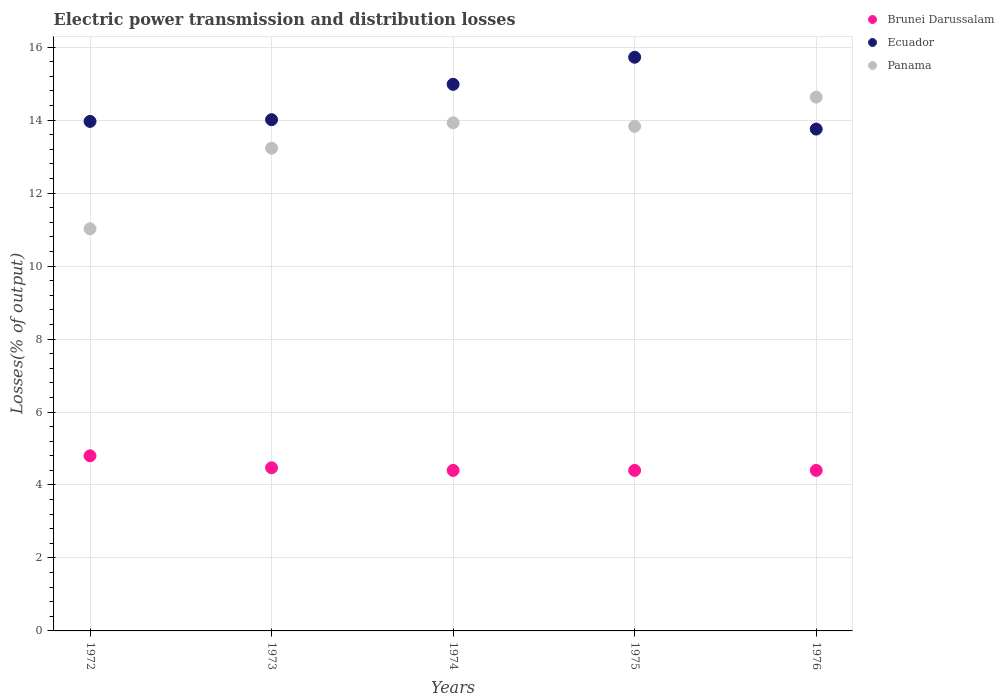How many different coloured dotlines are there?
Offer a very short reply. 3. Across all years, what is the maximum electric power transmission and distribution losses in Brunei Darussalam?
Ensure brevity in your answer.  4.8. Across all years, what is the minimum electric power transmission and distribution losses in Ecuador?
Provide a succinct answer. 13.76. In which year was the electric power transmission and distribution losses in Brunei Darussalam maximum?
Your answer should be very brief. 1972. In which year was the electric power transmission and distribution losses in Brunei Darussalam minimum?
Your response must be concise. 1974. What is the total electric power transmission and distribution losses in Ecuador in the graph?
Keep it short and to the point. 72.44. What is the difference between the electric power transmission and distribution losses in Ecuador in 1973 and that in 1976?
Your answer should be compact. 0.26. What is the difference between the electric power transmission and distribution losses in Brunei Darussalam in 1972 and the electric power transmission and distribution losses in Panama in 1976?
Offer a very short reply. -9.83. What is the average electric power transmission and distribution losses in Ecuador per year?
Your answer should be very brief. 14.49. In the year 1973, what is the difference between the electric power transmission and distribution losses in Panama and electric power transmission and distribution losses in Ecuador?
Ensure brevity in your answer.  -0.78. In how many years, is the electric power transmission and distribution losses in Brunei Darussalam greater than 6.8 %?
Your answer should be compact. 0. What is the ratio of the electric power transmission and distribution losses in Brunei Darussalam in 1972 to that in 1976?
Give a very brief answer. 1.09. Is the difference between the electric power transmission and distribution losses in Panama in 1973 and 1974 greater than the difference between the electric power transmission and distribution losses in Ecuador in 1973 and 1974?
Offer a terse response. Yes. What is the difference between the highest and the second highest electric power transmission and distribution losses in Ecuador?
Offer a very short reply. 0.74. What is the difference between the highest and the lowest electric power transmission and distribution losses in Ecuador?
Provide a succinct answer. 1.97. Is the sum of the electric power transmission and distribution losses in Ecuador in 1972 and 1973 greater than the maximum electric power transmission and distribution losses in Brunei Darussalam across all years?
Keep it short and to the point. Yes. Is it the case that in every year, the sum of the electric power transmission and distribution losses in Ecuador and electric power transmission and distribution losses in Brunei Darussalam  is greater than the electric power transmission and distribution losses in Panama?
Your answer should be compact. Yes. Does the electric power transmission and distribution losses in Brunei Darussalam monotonically increase over the years?
Provide a succinct answer. No. How many dotlines are there?
Ensure brevity in your answer.  3. How many years are there in the graph?
Make the answer very short. 5. What is the difference between two consecutive major ticks on the Y-axis?
Ensure brevity in your answer.  2. Does the graph contain grids?
Offer a terse response. Yes. What is the title of the graph?
Your answer should be very brief. Electric power transmission and distribution losses. Does "Gabon" appear as one of the legend labels in the graph?
Keep it short and to the point. No. What is the label or title of the X-axis?
Your answer should be very brief. Years. What is the label or title of the Y-axis?
Provide a short and direct response. Losses(% of output). What is the Losses(% of output) in Ecuador in 1972?
Provide a succinct answer. 13.97. What is the Losses(% of output) of Panama in 1972?
Give a very brief answer. 11.02. What is the Losses(% of output) in Brunei Darussalam in 1973?
Ensure brevity in your answer.  4.47. What is the Losses(% of output) in Ecuador in 1973?
Your response must be concise. 14.01. What is the Losses(% of output) of Panama in 1973?
Your response must be concise. 13.23. What is the Losses(% of output) in Ecuador in 1974?
Offer a very short reply. 14.98. What is the Losses(% of output) of Panama in 1974?
Your answer should be very brief. 13.93. What is the Losses(% of output) in Brunei Darussalam in 1975?
Provide a succinct answer. 4.4. What is the Losses(% of output) of Ecuador in 1975?
Provide a succinct answer. 15.72. What is the Losses(% of output) in Panama in 1975?
Provide a short and direct response. 13.83. What is the Losses(% of output) in Ecuador in 1976?
Your response must be concise. 13.76. What is the Losses(% of output) of Panama in 1976?
Your answer should be compact. 14.63. Across all years, what is the maximum Losses(% of output) in Brunei Darussalam?
Provide a succinct answer. 4.8. Across all years, what is the maximum Losses(% of output) in Ecuador?
Keep it short and to the point. 15.72. Across all years, what is the maximum Losses(% of output) in Panama?
Ensure brevity in your answer.  14.63. Across all years, what is the minimum Losses(% of output) in Ecuador?
Ensure brevity in your answer.  13.76. Across all years, what is the minimum Losses(% of output) in Panama?
Ensure brevity in your answer.  11.02. What is the total Losses(% of output) of Brunei Darussalam in the graph?
Offer a terse response. 22.47. What is the total Losses(% of output) in Ecuador in the graph?
Your answer should be very brief. 72.44. What is the total Losses(% of output) in Panama in the graph?
Offer a terse response. 66.64. What is the difference between the Losses(% of output) of Brunei Darussalam in 1972 and that in 1973?
Make the answer very short. 0.33. What is the difference between the Losses(% of output) of Ecuador in 1972 and that in 1973?
Provide a succinct answer. -0.05. What is the difference between the Losses(% of output) in Panama in 1972 and that in 1973?
Ensure brevity in your answer.  -2.21. What is the difference between the Losses(% of output) of Ecuador in 1972 and that in 1974?
Provide a short and direct response. -1.02. What is the difference between the Losses(% of output) in Panama in 1972 and that in 1974?
Your answer should be very brief. -2.91. What is the difference between the Losses(% of output) in Ecuador in 1972 and that in 1975?
Your answer should be very brief. -1.76. What is the difference between the Losses(% of output) in Panama in 1972 and that in 1975?
Give a very brief answer. -2.81. What is the difference between the Losses(% of output) of Ecuador in 1972 and that in 1976?
Offer a very short reply. 0.21. What is the difference between the Losses(% of output) of Panama in 1972 and that in 1976?
Offer a terse response. -3.61. What is the difference between the Losses(% of output) of Brunei Darussalam in 1973 and that in 1974?
Offer a very short reply. 0.07. What is the difference between the Losses(% of output) of Ecuador in 1973 and that in 1974?
Give a very brief answer. -0.97. What is the difference between the Losses(% of output) of Panama in 1973 and that in 1974?
Offer a very short reply. -0.7. What is the difference between the Losses(% of output) of Brunei Darussalam in 1973 and that in 1975?
Your response must be concise. 0.07. What is the difference between the Losses(% of output) in Ecuador in 1973 and that in 1975?
Offer a very short reply. -1.71. What is the difference between the Losses(% of output) in Panama in 1973 and that in 1975?
Make the answer very short. -0.6. What is the difference between the Losses(% of output) in Brunei Darussalam in 1973 and that in 1976?
Your response must be concise. 0.07. What is the difference between the Losses(% of output) in Ecuador in 1973 and that in 1976?
Give a very brief answer. 0.26. What is the difference between the Losses(% of output) of Panama in 1973 and that in 1976?
Make the answer very short. -1.4. What is the difference between the Losses(% of output) of Brunei Darussalam in 1974 and that in 1975?
Offer a very short reply. 0. What is the difference between the Losses(% of output) in Ecuador in 1974 and that in 1975?
Keep it short and to the point. -0.74. What is the difference between the Losses(% of output) in Panama in 1974 and that in 1975?
Ensure brevity in your answer.  0.1. What is the difference between the Losses(% of output) of Ecuador in 1974 and that in 1976?
Make the answer very short. 1.23. What is the difference between the Losses(% of output) in Panama in 1974 and that in 1976?
Offer a terse response. -0.7. What is the difference between the Losses(% of output) in Ecuador in 1975 and that in 1976?
Offer a terse response. 1.97. What is the difference between the Losses(% of output) of Panama in 1975 and that in 1976?
Give a very brief answer. -0.8. What is the difference between the Losses(% of output) in Brunei Darussalam in 1972 and the Losses(% of output) in Ecuador in 1973?
Your response must be concise. -9.21. What is the difference between the Losses(% of output) of Brunei Darussalam in 1972 and the Losses(% of output) of Panama in 1973?
Keep it short and to the point. -8.43. What is the difference between the Losses(% of output) of Ecuador in 1972 and the Losses(% of output) of Panama in 1973?
Your answer should be compact. 0.73. What is the difference between the Losses(% of output) in Brunei Darussalam in 1972 and the Losses(% of output) in Ecuador in 1974?
Provide a succinct answer. -10.18. What is the difference between the Losses(% of output) of Brunei Darussalam in 1972 and the Losses(% of output) of Panama in 1974?
Provide a succinct answer. -9.13. What is the difference between the Losses(% of output) in Ecuador in 1972 and the Losses(% of output) in Panama in 1974?
Provide a succinct answer. 0.04. What is the difference between the Losses(% of output) in Brunei Darussalam in 1972 and the Losses(% of output) in Ecuador in 1975?
Keep it short and to the point. -10.92. What is the difference between the Losses(% of output) of Brunei Darussalam in 1972 and the Losses(% of output) of Panama in 1975?
Keep it short and to the point. -9.03. What is the difference between the Losses(% of output) of Ecuador in 1972 and the Losses(% of output) of Panama in 1975?
Provide a succinct answer. 0.14. What is the difference between the Losses(% of output) of Brunei Darussalam in 1972 and the Losses(% of output) of Ecuador in 1976?
Your answer should be very brief. -8.96. What is the difference between the Losses(% of output) in Brunei Darussalam in 1972 and the Losses(% of output) in Panama in 1976?
Your answer should be very brief. -9.83. What is the difference between the Losses(% of output) of Ecuador in 1972 and the Losses(% of output) of Panama in 1976?
Your answer should be compact. -0.66. What is the difference between the Losses(% of output) of Brunei Darussalam in 1973 and the Losses(% of output) of Ecuador in 1974?
Offer a very short reply. -10.51. What is the difference between the Losses(% of output) in Brunei Darussalam in 1973 and the Losses(% of output) in Panama in 1974?
Ensure brevity in your answer.  -9.46. What is the difference between the Losses(% of output) in Ecuador in 1973 and the Losses(% of output) in Panama in 1974?
Offer a terse response. 0.08. What is the difference between the Losses(% of output) of Brunei Darussalam in 1973 and the Losses(% of output) of Ecuador in 1975?
Ensure brevity in your answer.  -11.25. What is the difference between the Losses(% of output) of Brunei Darussalam in 1973 and the Losses(% of output) of Panama in 1975?
Provide a short and direct response. -9.36. What is the difference between the Losses(% of output) of Ecuador in 1973 and the Losses(% of output) of Panama in 1975?
Ensure brevity in your answer.  0.18. What is the difference between the Losses(% of output) of Brunei Darussalam in 1973 and the Losses(% of output) of Ecuador in 1976?
Your answer should be very brief. -9.28. What is the difference between the Losses(% of output) in Brunei Darussalam in 1973 and the Losses(% of output) in Panama in 1976?
Keep it short and to the point. -10.16. What is the difference between the Losses(% of output) of Ecuador in 1973 and the Losses(% of output) of Panama in 1976?
Provide a short and direct response. -0.62. What is the difference between the Losses(% of output) in Brunei Darussalam in 1974 and the Losses(% of output) in Ecuador in 1975?
Your response must be concise. -11.32. What is the difference between the Losses(% of output) in Brunei Darussalam in 1974 and the Losses(% of output) in Panama in 1975?
Give a very brief answer. -9.43. What is the difference between the Losses(% of output) of Ecuador in 1974 and the Losses(% of output) of Panama in 1975?
Give a very brief answer. 1.15. What is the difference between the Losses(% of output) in Brunei Darussalam in 1974 and the Losses(% of output) in Ecuador in 1976?
Ensure brevity in your answer.  -9.36. What is the difference between the Losses(% of output) in Brunei Darussalam in 1974 and the Losses(% of output) in Panama in 1976?
Ensure brevity in your answer.  -10.23. What is the difference between the Losses(% of output) in Ecuador in 1974 and the Losses(% of output) in Panama in 1976?
Make the answer very short. 0.35. What is the difference between the Losses(% of output) of Brunei Darussalam in 1975 and the Losses(% of output) of Ecuador in 1976?
Your response must be concise. -9.36. What is the difference between the Losses(% of output) of Brunei Darussalam in 1975 and the Losses(% of output) of Panama in 1976?
Ensure brevity in your answer.  -10.23. What is the difference between the Losses(% of output) of Ecuador in 1975 and the Losses(% of output) of Panama in 1976?
Your answer should be compact. 1.09. What is the average Losses(% of output) of Brunei Darussalam per year?
Keep it short and to the point. 4.49. What is the average Losses(% of output) of Ecuador per year?
Offer a very short reply. 14.49. What is the average Losses(% of output) in Panama per year?
Ensure brevity in your answer.  13.33. In the year 1972, what is the difference between the Losses(% of output) of Brunei Darussalam and Losses(% of output) of Ecuador?
Offer a terse response. -9.17. In the year 1972, what is the difference between the Losses(% of output) in Brunei Darussalam and Losses(% of output) in Panama?
Give a very brief answer. -6.22. In the year 1972, what is the difference between the Losses(% of output) of Ecuador and Losses(% of output) of Panama?
Your answer should be very brief. 2.94. In the year 1973, what is the difference between the Losses(% of output) in Brunei Darussalam and Losses(% of output) in Ecuador?
Offer a very short reply. -9.54. In the year 1973, what is the difference between the Losses(% of output) of Brunei Darussalam and Losses(% of output) of Panama?
Offer a very short reply. -8.76. In the year 1973, what is the difference between the Losses(% of output) in Ecuador and Losses(% of output) in Panama?
Your response must be concise. 0.78. In the year 1974, what is the difference between the Losses(% of output) of Brunei Darussalam and Losses(% of output) of Ecuador?
Give a very brief answer. -10.58. In the year 1974, what is the difference between the Losses(% of output) of Brunei Darussalam and Losses(% of output) of Panama?
Give a very brief answer. -9.53. In the year 1974, what is the difference between the Losses(% of output) of Ecuador and Losses(% of output) of Panama?
Your answer should be very brief. 1.05. In the year 1975, what is the difference between the Losses(% of output) of Brunei Darussalam and Losses(% of output) of Ecuador?
Provide a succinct answer. -11.32. In the year 1975, what is the difference between the Losses(% of output) of Brunei Darussalam and Losses(% of output) of Panama?
Your answer should be compact. -9.43. In the year 1975, what is the difference between the Losses(% of output) in Ecuador and Losses(% of output) in Panama?
Give a very brief answer. 1.9. In the year 1976, what is the difference between the Losses(% of output) of Brunei Darussalam and Losses(% of output) of Ecuador?
Your answer should be very brief. -9.36. In the year 1976, what is the difference between the Losses(% of output) of Brunei Darussalam and Losses(% of output) of Panama?
Your answer should be compact. -10.23. In the year 1976, what is the difference between the Losses(% of output) in Ecuador and Losses(% of output) in Panama?
Give a very brief answer. -0.87. What is the ratio of the Losses(% of output) of Brunei Darussalam in 1972 to that in 1973?
Your answer should be very brief. 1.07. What is the ratio of the Losses(% of output) of Panama in 1972 to that in 1973?
Offer a terse response. 0.83. What is the ratio of the Losses(% of output) in Brunei Darussalam in 1972 to that in 1974?
Make the answer very short. 1.09. What is the ratio of the Losses(% of output) of Ecuador in 1972 to that in 1974?
Provide a short and direct response. 0.93. What is the ratio of the Losses(% of output) in Panama in 1972 to that in 1974?
Provide a short and direct response. 0.79. What is the ratio of the Losses(% of output) in Ecuador in 1972 to that in 1975?
Your answer should be compact. 0.89. What is the ratio of the Losses(% of output) of Panama in 1972 to that in 1975?
Provide a short and direct response. 0.8. What is the ratio of the Losses(% of output) in Brunei Darussalam in 1972 to that in 1976?
Keep it short and to the point. 1.09. What is the ratio of the Losses(% of output) of Ecuador in 1972 to that in 1976?
Offer a very short reply. 1.02. What is the ratio of the Losses(% of output) of Panama in 1972 to that in 1976?
Your answer should be very brief. 0.75. What is the ratio of the Losses(% of output) in Brunei Darussalam in 1973 to that in 1974?
Your answer should be very brief. 1.02. What is the ratio of the Losses(% of output) of Ecuador in 1973 to that in 1974?
Your response must be concise. 0.94. What is the ratio of the Losses(% of output) in Panama in 1973 to that in 1974?
Ensure brevity in your answer.  0.95. What is the ratio of the Losses(% of output) of Brunei Darussalam in 1973 to that in 1975?
Your answer should be compact. 1.02. What is the ratio of the Losses(% of output) of Ecuador in 1973 to that in 1975?
Your answer should be compact. 0.89. What is the ratio of the Losses(% of output) of Panama in 1973 to that in 1975?
Offer a terse response. 0.96. What is the ratio of the Losses(% of output) in Brunei Darussalam in 1973 to that in 1976?
Your response must be concise. 1.02. What is the ratio of the Losses(% of output) in Ecuador in 1973 to that in 1976?
Give a very brief answer. 1.02. What is the ratio of the Losses(% of output) in Panama in 1973 to that in 1976?
Provide a short and direct response. 0.9. What is the ratio of the Losses(% of output) in Brunei Darussalam in 1974 to that in 1975?
Provide a succinct answer. 1. What is the ratio of the Losses(% of output) in Ecuador in 1974 to that in 1975?
Your response must be concise. 0.95. What is the ratio of the Losses(% of output) in Brunei Darussalam in 1974 to that in 1976?
Your answer should be compact. 1. What is the ratio of the Losses(% of output) of Ecuador in 1974 to that in 1976?
Your response must be concise. 1.09. What is the ratio of the Losses(% of output) in Panama in 1974 to that in 1976?
Provide a succinct answer. 0.95. What is the ratio of the Losses(% of output) in Ecuador in 1975 to that in 1976?
Your response must be concise. 1.14. What is the ratio of the Losses(% of output) of Panama in 1975 to that in 1976?
Give a very brief answer. 0.95. What is the difference between the highest and the second highest Losses(% of output) in Brunei Darussalam?
Your answer should be very brief. 0.33. What is the difference between the highest and the second highest Losses(% of output) in Ecuador?
Give a very brief answer. 0.74. What is the difference between the highest and the second highest Losses(% of output) in Panama?
Ensure brevity in your answer.  0.7. What is the difference between the highest and the lowest Losses(% of output) of Ecuador?
Ensure brevity in your answer.  1.97. What is the difference between the highest and the lowest Losses(% of output) in Panama?
Provide a succinct answer. 3.61. 